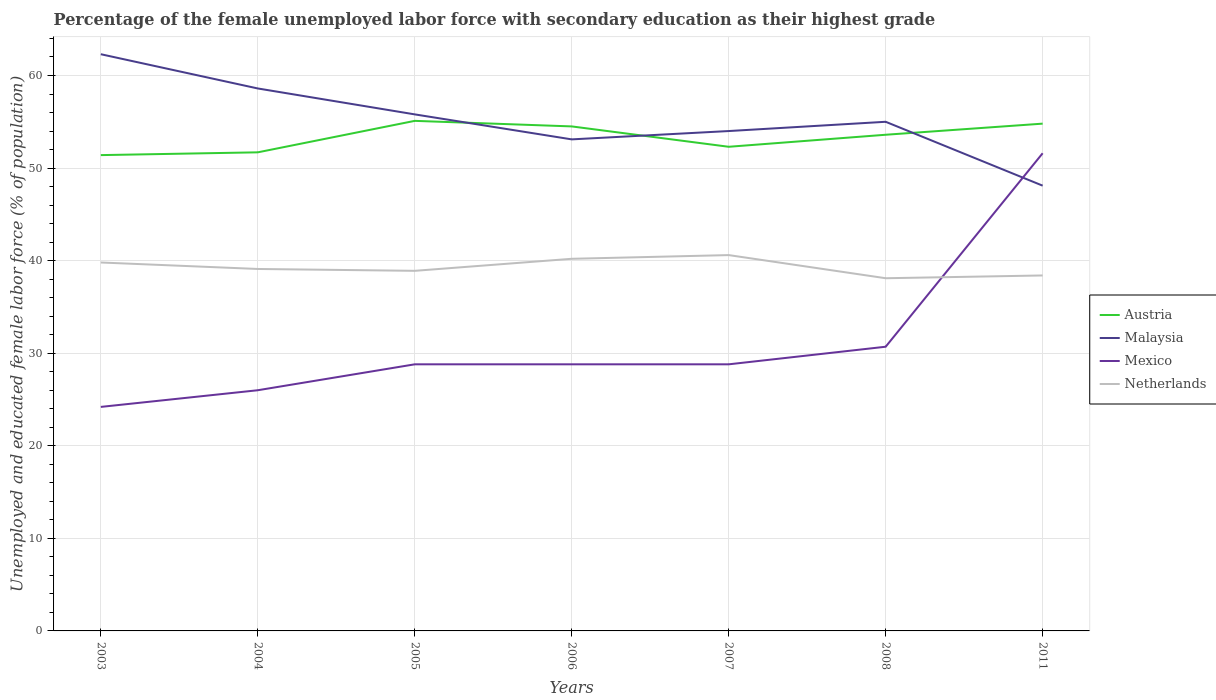How many different coloured lines are there?
Make the answer very short. 4. Does the line corresponding to Austria intersect with the line corresponding to Netherlands?
Give a very brief answer. No. Is the number of lines equal to the number of legend labels?
Make the answer very short. Yes. Across all years, what is the maximum percentage of the unemployed female labor force with secondary education in Austria?
Your response must be concise. 51.4. In which year was the percentage of the unemployed female labor force with secondary education in Malaysia maximum?
Provide a short and direct response. 2011. What is the total percentage of the unemployed female labor force with secondary education in Mexico in the graph?
Your answer should be compact. -25.6. What is the difference between the highest and the second highest percentage of the unemployed female labor force with secondary education in Netherlands?
Your answer should be compact. 2.5. What is the difference between the highest and the lowest percentage of the unemployed female labor force with secondary education in Austria?
Your answer should be very brief. 4. Is the percentage of the unemployed female labor force with secondary education in Austria strictly greater than the percentage of the unemployed female labor force with secondary education in Mexico over the years?
Your answer should be compact. No. What is the difference between two consecutive major ticks on the Y-axis?
Provide a short and direct response. 10. Are the values on the major ticks of Y-axis written in scientific E-notation?
Provide a succinct answer. No. Where does the legend appear in the graph?
Ensure brevity in your answer.  Center right. How are the legend labels stacked?
Ensure brevity in your answer.  Vertical. What is the title of the graph?
Your response must be concise. Percentage of the female unemployed labor force with secondary education as their highest grade. Does "Middle income" appear as one of the legend labels in the graph?
Your answer should be compact. No. What is the label or title of the Y-axis?
Your answer should be compact. Unemployed and educated female labor force (% of population). What is the Unemployed and educated female labor force (% of population) of Austria in 2003?
Your response must be concise. 51.4. What is the Unemployed and educated female labor force (% of population) in Malaysia in 2003?
Provide a succinct answer. 62.3. What is the Unemployed and educated female labor force (% of population) in Mexico in 2003?
Your response must be concise. 24.2. What is the Unemployed and educated female labor force (% of population) in Netherlands in 2003?
Keep it short and to the point. 39.8. What is the Unemployed and educated female labor force (% of population) in Austria in 2004?
Give a very brief answer. 51.7. What is the Unemployed and educated female labor force (% of population) in Malaysia in 2004?
Ensure brevity in your answer.  58.6. What is the Unemployed and educated female labor force (% of population) in Netherlands in 2004?
Your answer should be compact. 39.1. What is the Unemployed and educated female labor force (% of population) of Austria in 2005?
Give a very brief answer. 55.1. What is the Unemployed and educated female labor force (% of population) in Malaysia in 2005?
Ensure brevity in your answer.  55.8. What is the Unemployed and educated female labor force (% of population) of Mexico in 2005?
Your answer should be very brief. 28.8. What is the Unemployed and educated female labor force (% of population) in Netherlands in 2005?
Make the answer very short. 38.9. What is the Unemployed and educated female labor force (% of population) in Austria in 2006?
Make the answer very short. 54.5. What is the Unemployed and educated female labor force (% of population) of Malaysia in 2006?
Your answer should be very brief. 53.1. What is the Unemployed and educated female labor force (% of population) in Mexico in 2006?
Your answer should be very brief. 28.8. What is the Unemployed and educated female labor force (% of population) of Netherlands in 2006?
Your response must be concise. 40.2. What is the Unemployed and educated female labor force (% of population) in Austria in 2007?
Offer a very short reply. 52.3. What is the Unemployed and educated female labor force (% of population) in Malaysia in 2007?
Provide a succinct answer. 54. What is the Unemployed and educated female labor force (% of population) in Mexico in 2007?
Provide a short and direct response. 28.8. What is the Unemployed and educated female labor force (% of population) of Netherlands in 2007?
Provide a short and direct response. 40.6. What is the Unemployed and educated female labor force (% of population) in Austria in 2008?
Ensure brevity in your answer.  53.6. What is the Unemployed and educated female labor force (% of population) of Malaysia in 2008?
Give a very brief answer. 55. What is the Unemployed and educated female labor force (% of population) in Mexico in 2008?
Provide a succinct answer. 30.7. What is the Unemployed and educated female labor force (% of population) of Netherlands in 2008?
Offer a terse response. 38.1. What is the Unemployed and educated female labor force (% of population) in Austria in 2011?
Provide a short and direct response. 54.8. What is the Unemployed and educated female labor force (% of population) in Malaysia in 2011?
Provide a short and direct response. 48.1. What is the Unemployed and educated female labor force (% of population) of Mexico in 2011?
Your answer should be compact. 51.6. What is the Unemployed and educated female labor force (% of population) in Netherlands in 2011?
Offer a very short reply. 38.4. Across all years, what is the maximum Unemployed and educated female labor force (% of population) of Austria?
Keep it short and to the point. 55.1. Across all years, what is the maximum Unemployed and educated female labor force (% of population) of Malaysia?
Keep it short and to the point. 62.3. Across all years, what is the maximum Unemployed and educated female labor force (% of population) in Mexico?
Offer a very short reply. 51.6. Across all years, what is the maximum Unemployed and educated female labor force (% of population) in Netherlands?
Ensure brevity in your answer.  40.6. Across all years, what is the minimum Unemployed and educated female labor force (% of population) in Austria?
Provide a short and direct response. 51.4. Across all years, what is the minimum Unemployed and educated female labor force (% of population) of Malaysia?
Ensure brevity in your answer.  48.1. Across all years, what is the minimum Unemployed and educated female labor force (% of population) in Mexico?
Give a very brief answer. 24.2. Across all years, what is the minimum Unemployed and educated female labor force (% of population) in Netherlands?
Your answer should be very brief. 38.1. What is the total Unemployed and educated female labor force (% of population) of Austria in the graph?
Ensure brevity in your answer.  373.4. What is the total Unemployed and educated female labor force (% of population) of Malaysia in the graph?
Provide a short and direct response. 386.9. What is the total Unemployed and educated female labor force (% of population) of Mexico in the graph?
Keep it short and to the point. 218.9. What is the total Unemployed and educated female labor force (% of population) of Netherlands in the graph?
Make the answer very short. 275.1. What is the difference between the Unemployed and educated female labor force (% of population) in Austria in 2003 and that in 2004?
Your response must be concise. -0.3. What is the difference between the Unemployed and educated female labor force (% of population) in Netherlands in 2003 and that in 2004?
Offer a terse response. 0.7. What is the difference between the Unemployed and educated female labor force (% of population) in Austria in 2003 and that in 2005?
Give a very brief answer. -3.7. What is the difference between the Unemployed and educated female labor force (% of population) of Malaysia in 2003 and that in 2005?
Provide a succinct answer. 6.5. What is the difference between the Unemployed and educated female labor force (% of population) in Malaysia in 2003 and that in 2006?
Offer a very short reply. 9.2. What is the difference between the Unemployed and educated female labor force (% of population) of Mexico in 2003 and that in 2006?
Offer a very short reply. -4.6. What is the difference between the Unemployed and educated female labor force (% of population) of Austria in 2003 and that in 2007?
Offer a very short reply. -0.9. What is the difference between the Unemployed and educated female labor force (% of population) of Malaysia in 2003 and that in 2007?
Your answer should be very brief. 8.3. What is the difference between the Unemployed and educated female labor force (% of population) in Netherlands in 2003 and that in 2007?
Provide a short and direct response. -0.8. What is the difference between the Unemployed and educated female labor force (% of population) in Austria in 2003 and that in 2008?
Keep it short and to the point. -2.2. What is the difference between the Unemployed and educated female labor force (% of population) in Malaysia in 2003 and that in 2008?
Give a very brief answer. 7.3. What is the difference between the Unemployed and educated female labor force (% of population) of Netherlands in 2003 and that in 2008?
Offer a very short reply. 1.7. What is the difference between the Unemployed and educated female labor force (% of population) in Austria in 2003 and that in 2011?
Give a very brief answer. -3.4. What is the difference between the Unemployed and educated female labor force (% of population) in Mexico in 2003 and that in 2011?
Ensure brevity in your answer.  -27.4. What is the difference between the Unemployed and educated female labor force (% of population) of Netherlands in 2003 and that in 2011?
Offer a very short reply. 1.4. What is the difference between the Unemployed and educated female labor force (% of population) in Mexico in 2004 and that in 2005?
Offer a very short reply. -2.8. What is the difference between the Unemployed and educated female labor force (% of population) of Austria in 2004 and that in 2006?
Offer a very short reply. -2.8. What is the difference between the Unemployed and educated female labor force (% of population) in Mexico in 2004 and that in 2006?
Provide a short and direct response. -2.8. What is the difference between the Unemployed and educated female labor force (% of population) of Netherlands in 2004 and that in 2006?
Provide a short and direct response. -1.1. What is the difference between the Unemployed and educated female labor force (% of population) in Austria in 2004 and that in 2007?
Make the answer very short. -0.6. What is the difference between the Unemployed and educated female labor force (% of population) of Mexico in 2004 and that in 2007?
Ensure brevity in your answer.  -2.8. What is the difference between the Unemployed and educated female labor force (% of population) of Netherlands in 2004 and that in 2007?
Your response must be concise. -1.5. What is the difference between the Unemployed and educated female labor force (% of population) in Austria in 2004 and that in 2008?
Your answer should be very brief. -1.9. What is the difference between the Unemployed and educated female labor force (% of population) of Malaysia in 2004 and that in 2008?
Provide a short and direct response. 3.6. What is the difference between the Unemployed and educated female labor force (% of population) in Mexico in 2004 and that in 2008?
Provide a short and direct response. -4.7. What is the difference between the Unemployed and educated female labor force (% of population) of Austria in 2004 and that in 2011?
Your answer should be very brief. -3.1. What is the difference between the Unemployed and educated female labor force (% of population) of Mexico in 2004 and that in 2011?
Give a very brief answer. -25.6. What is the difference between the Unemployed and educated female labor force (% of population) in Netherlands in 2004 and that in 2011?
Provide a short and direct response. 0.7. What is the difference between the Unemployed and educated female labor force (% of population) in Austria in 2005 and that in 2006?
Give a very brief answer. 0.6. What is the difference between the Unemployed and educated female labor force (% of population) in Netherlands in 2005 and that in 2006?
Offer a terse response. -1.3. What is the difference between the Unemployed and educated female labor force (% of population) of Mexico in 2005 and that in 2007?
Give a very brief answer. 0. What is the difference between the Unemployed and educated female labor force (% of population) in Austria in 2005 and that in 2008?
Provide a short and direct response. 1.5. What is the difference between the Unemployed and educated female labor force (% of population) of Malaysia in 2005 and that in 2008?
Give a very brief answer. 0.8. What is the difference between the Unemployed and educated female labor force (% of population) of Netherlands in 2005 and that in 2008?
Offer a terse response. 0.8. What is the difference between the Unemployed and educated female labor force (% of population) of Austria in 2005 and that in 2011?
Your response must be concise. 0.3. What is the difference between the Unemployed and educated female labor force (% of population) in Malaysia in 2005 and that in 2011?
Give a very brief answer. 7.7. What is the difference between the Unemployed and educated female labor force (% of population) in Mexico in 2005 and that in 2011?
Offer a very short reply. -22.8. What is the difference between the Unemployed and educated female labor force (% of population) of Netherlands in 2005 and that in 2011?
Your answer should be very brief. 0.5. What is the difference between the Unemployed and educated female labor force (% of population) of Austria in 2006 and that in 2007?
Offer a terse response. 2.2. What is the difference between the Unemployed and educated female labor force (% of population) in Malaysia in 2006 and that in 2007?
Provide a succinct answer. -0.9. What is the difference between the Unemployed and educated female labor force (% of population) in Mexico in 2006 and that in 2007?
Offer a very short reply. 0. What is the difference between the Unemployed and educated female labor force (% of population) in Malaysia in 2006 and that in 2008?
Provide a succinct answer. -1.9. What is the difference between the Unemployed and educated female labor force (% of population) in Mexico in 2006 and that in 2008?
Your answer should be compact. -1.9. What is the difference between the Unemployed and educated female labor force (% of population) in Austria in 2006 and that in 2011?
Provide a short and direct response. -0.3. What is the difference between the Unemployed and educated female labor force (% of population) of Malaysia in 2006 and that in 2011?
Keep it short and to the point. 5. What is the difference between the Unemployed and educated female labor force (% of population) in Mexico in 2006 and that in 2011?
Provide a short and direct response. -22.8. What is the difference between the Unemployed and educated female labor force (% of population) in Malaysia in 2007 and that in 2008?
Your answer should be compact. -1. What is the difference between the Unemployed and educated female labor force (% of population) in Mexico in 2007 and that in 2008?
Your answer should be very brief. -1.9. What is the difference between the Unemployed and educated female labor force (% of population) in Mexico in 2007 and that in 2011?
Keep it short and to the point. -22.8. What is the difference between the Unemployed and educated female labor force (% of population) of Netherlands in 2007 and that in 2011?
Offer a very short reply. 2.2. What is the difference between the Unemployed and educated female labor force (% of population) of Austria in 2008 and that in 2011?
Give a very brief answer. -1.2. What is the difference between the Unemployed and educated female labor force (% of population) in Mexico in 2008 and that in 2011?
Provide a short and direct response. -20.9. What is the difference between the Unemployed and educated female labor force (% of population) of Austria in 2003 and the Unemployed and educated female labor force (% of population) of Mexico in 2004?
Provide a short and direct response. 25.4. What is the difference between the Unemployed and educated female labor force (% of population) in Austria in 2003 and the Unemployed and educated female labor force (% of population) in Netherlands in 2004?
Offer a very short reply. 12.3. What is the difference between the Unemployed and educated female labor force (% of population) in Malaysia in 2003 and the Unemployed and educated female labor force (% of population) in Mexico in 2004?
Provide a succinct answer. 36.3. What is the difference between the Unemployed and educated female labor force (% of population) in Malaysia in 2003 and the Unemployed and educated female labor force (% of population) in Netherlands in 2004?
Keep it short and to the point. 23.2. What is the difference between the Unemployed and educated female labor force (% of population) in Mexico in 2003 and the Unemployed and educated female labor force (% of population) in Netherlands in 2004?
Offer a terse response. -14.9. What is the difference between the Unemployed and educated female labor force (% of population) of Austria in 2003 and the Unemployed and educated female labor force (% of population) of Malaysia in 2005?
Offer a terse response. -4.4. What is the difference between the Unemployed and educated female labor force (% of population) of Austria in 2003 and the Unemployed and educated female labor force (% of population) of Mexico in 2005?
Provide a short and direct response. 22.6. What is the difference between the Unemployed and educated female labor force (% of population) in Malaysia in 2003 and the Unemployed and educated female labor force (% of population) in Mexico in 2005?
Ensure brevity in your answer.  33.5. What is the difference between the Unemployed and educated female labor force (% of population) of Malaysia in 2003 and the Unemployed and educated female labor force (% of population) of Netherlands in 2005?
Provide a short and direct response. 23.4. What is the difference between the Unemployed and educated female labor force (% of population) of Mexico in 2003 and the Unemployed and educated female labor force (% of population) of Netherlands in 2005?
Your answer should be very brief. -14.7. What is the difference between the Unemployed and educated female labor force (% of population) of Austria in 2003 and the Unemployed and educated female labor force (% of population) of Malaysia in 2006?
Provide a succinct answer. -1.7. What is the difference between the Unemployed and educated female labor force (% of population) of Austria in 2003 and the Unemployed and educated female labor force (% of population) of Mexico in 2006?
Give a very brief answer. 22.6. What is the difference between the Unemployed and educated female labor force (% of population) of Malaysia in 2003 and the Unemployed and educated female labor force (% of population) of Mexico in 2006?
Provide a succinct answer. 33.5. What is the difference between the Unemployed and educated female labor force (% of population) of Malaysia in 2003 and the Unemployed and educated female labor force (% of population) of Netherlands in 2006?
Offer a very short reply. 22.1. What is the difference between the Unemployed and educated female labor force (% of population) in Austria in 2003 and the Unemployed and educated female labor force (% of population) in Mexico in 2007?
Your response must be concise. 22.6. What is the difference between the Unemployed and educated female labor force (% of population) of Austria in 2003 and the Unemployed and educated female labor force (% of population) of Netherlands in 2007?
Your answer should be compact. 10.8. What is the difference between the Unemployed and educated female labor force (% of population) of Malaysia in 2003 and the Unemployed and educated female labor force (% of population) of Mexico in 2007?
Your answer should be compact. 33.5. What is the difference between the Unemployed and educated female labor force (% of population) of Malaysia in 2003 and the Unemployed and educated female labor force (% of population) of Netherlands in 2007?
Offer a very short reply. 21.7. What is the difference between the Unemployed and educated female labor force (% of population) in Mexico in 2003 and the Unemployed and educated female labor force (% of population) in Netherlands in 2007?
Make the answer very short. -16.4. What is the difference between the Unemployed and educated female labor force (% of population) in Austria in 2003 and the Unemployed and educated female labor force (% of population) in Malaysia in 2008?
Your answer should be compact. -3.6. What is the difference between the Unemployed and educated female labor force (% of population) of Austria in 2003 and the Unemployed and educated female labor force (% of population) of Mexico in 2008?
Make the answer very short. 20.7. What is the difference between the Unemployed and educated female labor force (% of population) of Malaysia in 2003 and the Unemployed and educated female labor force (% of population) of Mexico in 2008?
Keep it short and to the point. 31.6. What is the difference between the Unemployed and educated female labor force (% of population) in Malaysia in 2003 and the Unemployed and educated female labor force (% of population) in Netherlands in 2008?
Provide a short and direct response. 24.2. What is the difference between the Unemployed and educated female labor force (% of population) in Austria in 2003 and the Unemployed and educated female labor force (% of population) in Malaysia in 2011?
Your answer should be compact. 3.3. What is the difference between the Unemployed and educated female labor force (% of population) of Austria in 2003 and the Unemployed and educated female labor force (% of population) of Mexico in 2011?
Your answer should be compact. -0.2. What is the difference between the Unemployed and educated female labor force (% of population) of Malaysia in 2003 and the Unemployed and educated female labor force (% of population) of Mexico in 2011?
Give a very brief answer. 10.7. What is the difference between the Unemployed and educated female labor force (% of population) of Malaysia in 2003 and the Unemployed and educated female labor force (% of population) of Netherlands in 2011?
Your response must be concise. 23.9. What is the difference between the Unemployed and educated female labor force (% of population) of Mexico in 2003 and the Unemployed and educated female labor force (% of population) of Netherlands in 2011?
Offer a terse response. -14.2. What is the difference between the Unemployed and educated female labor force (% of population) in Austria in 2004 and the Unemployed and educated female labor force (% of population) in Malaysia in 2005?
Provide a short and direct response. -4.1. What is the difference between the Unemployed and educated female labor force (% of population) in Austria in 2004 and the Unemployed and educated female labor force (% of population) in Mexico in 2005?
Give a very brief answer. 22.9. What is the difference between the Unemployed and educated female labor force (% of population) in Austria in 2004 and the Unemployed and educated female labor force (% of population) in Netherlands in 2005?
Your answer should be very brief. 12.8. What is the difference between the Unemployed and educated female labor force (% of population) in Malaysia in 2004 and the Unemployed and educated female labor force (% of population) in Mexico in 2005?
Offer a terse response. 29.8. What is the difference between the Unemployed and educated female labor force (% of population) of Malaysia in 2004 and the Unemployed and educated female labor force (% of population) of Netherlands in 2005?
Your answer should be compact. 19.7. What is the difference between the Unemployed and educated female labor force (% of population) of Mexico in 2004 and the Unemployed and educated female labor force (% of population) of Netherlands in 2005?
Offer a terse response. -12.9. What is the difference between the Unemployed and educated female labor force (% of population) in Austria in 2004 and the Unemployed and educated female labor force (% of population) in Malaysia in 2006?
Give a very brief answer. -1.4. What is the difference between the Unemployed and educated female labor force (% of population) in Austria in 2004 and the Unemployed and educated female labor force (% of population) in Mexico in 2006?
Make the answer very short. 22.9. What is the difference between the Unemployed and educated female labor force (% of population) in Austria in 2004 and the Unemployed and educated female labor force (% of population) in Netherlands in 2006?
Offer a very short reply. 11.5. What is the difference between the Unemployed and educated female labor force (% of population) in Malaysia in 2004 and the Unemployed and educated female labor force (% of population) in Mexico in 2006?
Keep it short and to the point. 29.8. What is the difference between the Unemployed and educated female labor force (% of population) of Austria in 2004 and the Unemployed and educated female labor force (% of population) of Mexico in 2007?
Your answer should be compact. 22.9. What is the difference between the Unemployed and educated female labor force (% of population) of Malaysia in 2004 and the Unemployed and educated female labor force (% of population) of Mexico in 2007?
Offer a terse response. 29.8. What is the difference between the Unemployed and educated female labor force (% of population) in Malaysia in 2004 and the Unemployed and educated female labor force (% of population) in Netherlands in 2007?
Your answer should be compact. 18. What is the difference between the Unemployed and educated female labor force (% of population) in Mexico in 2004 and the Unemployed and educated female labor force (% of population) in Netherlands in 2007?
Your answer should be very brief. -14.6. What is the difference between the Unemployed and educated female labor force (% of population) in Austria in 2004 and the Unemployed and educated female labor force (% of population) in Malaysia in 2008?
Your answer should be very brief. -3.3. What is the difference between the Unemployed and educated female labor force (% of population) in Malaysia in 2004 and the Unemployed and educated female labor force (% of population) in Mexico in 2008?
Provide a short and direct response. 27.9. What is the difference between the Unemployed and educated female labor force (% of population) in Malaysia in 2004 and the Unemployed and educated female labor force (% of population) in Mexico in 2011?
Offer a very short reply. 7. What is the difference between the Unemployed and educated female labor force (% of population) in Malaysia in 2004 and the Unemployed and educated female labor force (% of population) in Netherlands in 2011?
Keep it short and to the point. 20.2. What is the difference between the Unemployed and educated female labor force (% of population) in Austria in 2005 and the Unemployed and educated female labor force (% of population) in Malaysia in 2006?
Keep it short and to the point. 2. What is the difference between the Unemployed and educated female labor force (% of population) in Austria in 2005 and the Unemployed and educated female labor force (% of population) in Mexico in 2006?
Your response must be concise. 26.3. What is the difference between the Unemployed and educated female labor force (% of population) in Austria in 2005 and the Unemployed and educated female labor force (% of population) in Netherlands in 2006?
Your answer should be compact. 14.9. What is the difference between the Unemployed and educated female labor force (% of population) in Malaysia in 2005 and the Unemployed and educated female labor force (% of population) in Mexico in 2006?
Keep it short and to the point. 27. What is the difference between the Unemployed and educated female labor force (% of population) in Mexico in 2005 and the Unemployed and educated female labor force (% of population) in Netherlands in 2006?
Keep it short and to the point. -11.4. What is the difference between the Unemployed and educated female labor force (% of population) of Austria in 2005 and the Unemployed and educated female labor force (% of population) of Mexico in 2007?
Provide a short and direct response. 26.3. What is the difference between the Unemployed and educated female labor force (% of population) of Austria in 2005 and the Unemployed and educated female labor force (% of population) of Netherlands in 2007?
Offer a very short reply. 14.5. What is the difference between the Unemployed and educated female labor force (% of population) of Malaysia in 2005 and the Unemployed and educated female labor force (% of population) of Mexico in 2007?
Your response must be concise. 27. What is the difference between the Unemployed and educated female labor force (% of population) of Malaysia in 2005 and the Unemployed and educated female labor force (% of population) of Netherlands in 2007?
Give a very brief answer. 15.2. What is the difference between the Unemployed and educated female labor force (% of population) of Mexico in 2005 and the Unemployed and educated female labor force (% of population) of Netherlands in 2007?
Keep it short and to the point. -11.8. What is the difference between the Unemployed and educated female labor force (% of population) of Austria in 2005 and the Unemployed and educated female labor force (% of population) of Malaysia in 2008?
Make the answer very short. 0.1. What is the difference between the Unemployed and educated female labor force (% of population) in Austria in 2005 and the Unemployed and educated female labor force (% of population) in Mexico in 2008?
Ensure brevity in your answer.  24.4. What is the difference between the Unemployed and educated female labor force (% of population) in Malaysia in 2005 and the Unemployed and educated female labor force (% of population) in Mexico in 2008?
Provide a succinct answer. 25.1. What is the difference between the Unemployed and educated female labor force (% of population) of Malaysia in 2005 and the Unemployed and educated female labor force (% of population) of Netherlands in 2008?
Your response must be concise. 17.7. What is the difference between the Unemployed and educated female labor force (% of population) in Mexico in 2005 and the Unemployed and educated female labor force (% of population) in Netherlands in 2008?
Your answer should be very brief. -9.3. What is the difference between the Unemployed and educated female labor force (% of population) of Austria in 2005 and the Unemployed and educated female labor force (% of population) of Mexico in 2011?
Offer a terse response. 3.5. What is the difference between the Unemployed and educated female labor force (% of population) of Austria in 2005 and the Unemployed and educated female labor force (% of population) of Netherlands in 2011?
Offer a terse response. 16.7. What is the difference between the Unemployed and educated female labor force (% of population) of Austria in 2006 and the Unemployed and educated female labor force (% of population) of Mexico in 2007?
Provide a succinct answer. 25.7. What is the difference between the Unemployed and educated female labor force (% of population) of Malaysia in 2006 and the Unemployed and educated female labor force (% of population) of Mexico in 2007?
Your response must be concise. 24.3. What is the difference between the Unemployed and educated female labor force (% of population) of Austria in 2006 and the Unemployed and educated female labor force (% of population) of Malaysia in 2008?
Provide a short and direct response. -0.5. What is the difference between the Unemployed and educated female labor force (% of population) of Austria in 2006 and the Unemployed and educated female labor force (% of population) of Mexico in 2008?
Offer a very short reply. 23.8. What is the difference between the Unemployed and educated female labor force (% of population) in Malaysia in 2006 and the Unemployed and educated female labor force (% of population) in Mexico in 2008?
Your answer should be compact. 22.4. What is the difference between the Unemployed and educated female labor force (% of population) of Mexico in 2006 and the Unemployed and educated female labor force (% of population) of Netherlands in 2008?
Offer a very short reply. -9.3. What is the difference between the Unemployed and educated female labor force (% of population) of Austria in 2006 and the Unemployed and educated female labor force (% of population) of Malaysia in 2011?
Offer a terse response. 6.4. What is the difference between the Unemployed and educated female labor force (% of population) in Austria in 2006 and the Unemployed and educated female labor force (% of population) in Mexico in 2011?
Provide a short and direct response. 2.9. What is the difference between the Unemployed and educated female labor force (% of population) in Malaysia in 2006 and the Unemployed and educated female labor force (% of population) in Mexico in 2011?
Provide a succinct answer. 1.5. What is the difference between the Unemployed and educated female labor force (% of population) of Malaysia in 2006 and the Unemployed and educated female labor force (% of population) of Netherlands in 2011?
Provide a short and direct response. 14.7. What is the difference between the Unemployed and educated female labor force (% of population) of Austria in 2007 and the Unemployed and educated female labor force (% of population) of Malaysia in 2008?
Make the answer very short. -2.7. What is the difference between the Unemployed and educated female labor force (% of population) of Austria in 2007 and the Unemployed and educated female labor force (% of population) of Mexico in 2008?
Keep it short and to the point. 21.6. What is the difference between the Unemployed and educated female labor force (% of population) of Malaysia in 2007 and the Unemployed and educated female labor force (% of population) of Mexico in 2008?
Ensure brevity in your answer.  23.3. What is the difference between the Unemployed and educated female labor force (% of population) in Mexico in 2007 and the Unemployed and educated female labor force (% of population) in Netherlands in 2008?
Your answer should be very brief. -9.3. What is the difference between the Unemployed and educated female labor force (% of population) of Austria in 2007 and the Unemployed and educated female labor force (% of population) of Netherlands in 2011?
Ensure brevity in your answer.  13.9. What is the difference between the Unemployed and educated female labor force (% of population) in Malaysia in 2007 and the Unemployed and educated female labor force (% of population) in Netherlands in 2011?
Your response must be concise. 15.6. What is the difference between the Unemployed and educated female labor force (% of population) in Malaysia in 2008 and the Unemployed and educated female labor force (% of population) in Mexico in 2011?
Your answer should be very brief. 3.4. What is the difference between the Unemployed and educated female labor force (% of population) of Malaysia in 2008 and the Unemployed and educated female labor force (% of population) of Netherlands in 2011?
Offer a very short reply. 16.6. What is the average Unemployed and educated female labor force (% of population) in Austria per year?
Give a very brief answer. 53.34. What is the average Unemployed and educated female labor force (% of population) in Malaysia per year?
Provide a short and direct response. 55.27. What is the average Unemployed and educated female labor force (% of population) of Mexico per year?
Your answer should be very brief. 31.27. What is the average Unemployed and educated female labor force (% of population) in Netherlands per year?
Make the answer very short. 39.3. In the year 2003, what is the difference between the Unemployed and educated female labor force (% of population) in Austria and Unemployed and educated female labor force (% of population) in Malaysia?
Offer a very short reply. -10.9. In the year 2003, what is the difference between the Unemployed and educated female labor force (% of population) in Austria and Unemployed and educated female labor force (% of population) in Mexico?
Ensure brevity in your answer.  27.2. In the year 2003, what is the difference between the Unemployed and educated female labor force (% of population) of Austria and Unemployed and educated female labor force (% of population) of Netherlands?
Your answer should be compact. 11.6. In the year 2003, what is the difference between the Unemployed and educated female labor force (% of population) in Malaysia and Unemployed and educated female labor force (% of population) in Mexico?
Ensure brevity in your answer.  38.1. In the year 2003, what is the difference between the Unemployed and educated female labor force (% of population) of Mexico and Unemployed and educated female labor force (% of population) of Netherlands?
Make the answer very short. -15.6. In the year 2004, what is the difference between the Unemployed and educated female labor force (% of population) of Austria and Unemployed and educated female labor force (% of population) of Malaysia?
Keep it short and to the point. -6.9. In the year 2004, what is the difference between the Unemployed and educated female labor force (% of population) of Austria and Unemployed and educated female labor force (% of population) of Mexico?
Ensure brevity in your answer.  25.7. In the year 2004, what is the difference between the Unemployed and educated female labor force (% of population) in Austria and Unemployed and educated female labor force (% of population) in Netherlands?
Your response must be concise. 12.6. In the year 2004, what is the difference between the Unemployed and educated female labor force (% of population) in Malaysia and Unemployed and educated female labor force (% of population) in Mexico?
Make the answer very short. 32.6. In the year 2004, what is the difference between the Unemployed and educated female labor force (% of population) of Malaysia and Unemployed and educated female labor force (% of population) of Netherlands?
Your answer should be very brief. 19.5. In the year 2004, what is the difference between the Unemployed and educated female labor force (% of population) in Mexico and Unemployed and educated female labor force (% of population) in Netherlands?
Your answer should be compact. -13.1. In the year 2005, what is the difference between the Unemployed and educated female labor force (% of population) in Austria and Unemployed and educated female labor force (% of population) in Malaysia?
Your answer should be compact. -0.7. In the year 2005, what is the difference between the Unemployed and educated female labor force (% of population) in Austria and Unemployed and educated female labor force (% of population) in Mexico?
Offer a terse response. 26.3. In the year 2005, what is the difference between the Unemployed and educated female labor force (% of population) in Austria and Unemployed and educated female labor force (% of population) in Netherlands?
Keep it short and to the point. 16.2. In the year 2005, what is the difference between the Unemployed and educated female labor force (% of population) in Malaysia and Unemployed and educated female labor force (% of population) in Mexico?
Your answer should be very brief. 27. In the year 2006, what is the difference between the Unemployed and educated female labor force (% of population) in Austria and Unemployed and educated female labor force (% of population) in Malaysia?
Provide a short and direct response. 1.4. In the year 2006, what is the difference between the Unemployed and educated female labor force (% of population) of Austria and Unemployed and educated female labor force (% of population) of Mexico?
Offer a terse response. 25.7. In the year 2006, what is the difference between the Unemployed and educated female labor force (% of population) of Austria and Unemployed and educated female labor force (% of population) of Netherlands?
Ensure brevity in your answer.  14.3. In the year 2006, what is the difference between the Unemployed and educated female labor force (% of population) in Malaysia and Unemployed and educated female labor force (% of population) in Mexico?
Provide a succinct answer. 24.3. In the year 2006, what is the difference between the Unemployed and educated female labor force (% of population) of Malaysia and Unemployed and educated female labor force (% of population) of Netherlands?
Your response must be concise. 12.9. In the year 2006, what is the difference between the Unemployed and educated female labor force (% of population) of Mexico and Unemployed and educated female labor force (% of population) of Netherlands?
Offer a very short reply. -11.4. In the year 2007, what is the difference between the Unemployed and educated female labor force (% of population) in Austria and Unemployed and educated female labor force (% of population) in Malaysia?
Your answer should be compact. -1.7. In the year 2007, what is the difference between the Unemployed and educated female labor force (% of population) of Austria and Unemployed and educated female labor force (% of population) of Netherlands?
Make the answer very short. 11.7. In the year 2007, what is the difference between the Unemployed and educated female labor force (% of population) of Malaysia and Unemployed and educated female labor force (% of population) of Mexico?
Provide a succinct answer. 25.2. In the year 2007, what is the difference between the Unemployed and educated female labor force (% of population) in Mexico and Unemployed and educated female labor force (% of population) in Netherlands?
Keep it short and to the point. -11.8. In the year 2008, what is the difference between the Unemployed and educated female labor force (% of population) of Austria and Unemployed and educated female labor force (% of population) of Mexico?
Your response must be concise. 22.9. In the year 2008, what is the difference between the Unemployed and educated female labor force (% of population) in Austria and Unemployed and educated female labor force (% of population) in Netherlands?
Provide a succinct answer. 15.5. In the year 2008, what is the difference between the Unemployed and educated female labor force (% of population) in Malaysia and Unemployed and educated female labor force (% of population) in Mexico?
Give a very brief answer. 24.3. In the year 2011, what is the difference between the Unemployed and educated female labor force (% of population) of Malaysia and Unemployed and educated female labor force (% of population) of Mexico?
Your answer should be very brief. -3.5. In the year 2011, what is the difference between the Unemployed and educated female labor force (% of population) of Mexico and Unemployed and educated female labor force (% of population) of Netherlands?
Offer a very short reply. 13.2. What is the ratio of the Unemployed and educated female labor force (% of population) in Austria in 2003 to that in 2004?
Your response must be concise. 0.99. What is the ratio of the Unemployed and educated female labor force (% of population) in Malaysia in 2003 to that in 2004?
Provide a short and direct response. 1.06. What is the ratio of the Unemployed and educated female labor force (% of population) in Mexico in 2003 to that in 2004?
Keep it short and to the point. 0.93. What is the ratio of the Unemployed and educated female labor force (% of population) in Netherlands in 2003 to that in 2004?
Your answer should be compact. 1.02. What is the ratio of the Unemployed and educated female labor force (% of population) in Austria in 2003 to that in 2005?
Provide a short and direct response. 0.93. What is the ratio of the Unemployed and educated female labor force (% of population) in Malaysia in 2003 to that in 2005?
Offer a terse response. 1.12. What is the ratio of the Unemployed and educated female labor force (% of population) in Mexico in 2003 to that in 2005?
Your answer should be compact. 0.84. What is the ratio of the Unemployed and educated female labor force (% of population) of Netherlands in 2003 to that in 2005?
Offer a terse response. 1.02. What is the ratio of the Unemployed and educated female labor force (% of population) in Austria in 2003 to that in 2006?
Provide a succinct answer. 0.94. What is the ratio of the Unemployed and educated female labor force (% of population) of Malaysia in 2003 to that in 2006?
Provide a short and direct response. 1.17. What is the ratio of the Unemployed and educated female labor force (% of population) of Mexico in 2003 to that in 2006?
Your answer should be compact. 0.84. What is the ratio of the Unemployed and educated female labor force (% of population) in Netherlands in 2003 to that in 2006?
Keep it short and to the point. 0.99. What is the ratio of the Unemployed and educated female labor force (% of population) in Austria in 2003 to that in 2007?
Offer a terse response. 0.98. What is the ratio of the Unemployed and educated female labor force (% of population) of Malaysia in 2003 to that in 2007?
Provide a succinct answer. 1.15. What is the ratio of the Unemployed and educated female labor force (% of population) in Mexico in 2003 to that in 2007?
Your answer should be very brief. 0.84. What is the ratio of the Unemployed and educated female labor force (% of population) in Netherlands in 2003 to that in 2007?
Provide a succinct answer. 0.98. What is the ratio of the Unemployed and educated female labor force (% of population) in Austria in 2003 to that in 2008?
Ensure brevity in your answer.  0.96. What is the ratio of the Unemployed and educated female labor force (% of population) in Malaysia in 2003 to that in 2008?
Keep it short and to the point. 1.13. What is the ratio of the Unemployed and educated female labor force (% of population) in Mexico in 2003 to that in 2008?
Your response must be concise. 0.79. What is the ratio of the Unemployed and educated female labor force (% of population) of Netherlands in 2003 to that in 2008?
Provide a short and direct response. 1.04. What is the ratio of the Unemployed and educated female labor force (% of population) in Austria in 2003 to that in 2011?
Give a very brief answer. 0.94. What is the ratio of the Unemployed and educated female labor force (% of population) of Malaysia in 2003 to that in 2011?
Give a very brief answer. 1.3. What is the ratio of the Unemployed and educated female labor force (% of population) in Mexico in 2003 to that in 2011?
Keep it short and to the point. 0.47. What is the ratio of the Unemployed and educated female labor force (% of population) in Netherlands in 2003 to that in 2011?
Make the answer very short. 1.04. What is the ratio of the Unemployed and educated female labor force (% of population) of Austria in 2004 to that in 2005?
Ensure brevity in your answer.  0.94. What is the ratio of the Unemployed and educated female labor force (% of population) in Malaysia in 2004 to that in 2005?
Your answer should be very brief. 1.05. What is the ratio of the Unemployed and educated female labor force (% of population) of Mexico in 2004 to that in 2005?
Ensure brevity in your answer.  0.9. What is the ratio of the Unemployed and educated female labor force (% of population) of Austria in 2004 to that in 2006?
Make the answer very short. 0.95. What is the ratio of the Unemployed and educated female labor force (% of population) in Malaysia in 2004 to that in 2006?
Give a very brief answer. 1.1. What is the ratio of the Unemployed and educated female labor force (% of population) in Mexico in 2004 to that in 2006?
Ensure brevity in your answer.  0.9. What is the ratio of the Unemployed and educated female labor force (% of population) of Netherlands in 2004 to that in 2006?
Your response must be concise. 0.97. What is the ratio of the Unemployed and educated female labor force (% of population) of Austria in 2004 to that in 2007?
Offer a terse response. 0.99. What is the ratio of the Unemployed and educated female labor force (% of population) of Malaysia in 2004 to that in 2007?
Keep it short and to the point. 1.09. What is the ratio of the Unemployed and educated female labor force (% of population) of Mexico in 2004 to that in 2007?
Make the answer very short. 0.9. What is the ratio of the Unemployed and educated female labor force (% of population) of Netherlands in 2004 to that in 2007?
Keep it short and to the point. 0.96. What is the ratio of the Unemployed and educated female labor force (% of population) of Austria in 2004 to that in 2008?
Your answer should be very brief. 0.96. What is the ratio of the Unemployed and educated female labor force (% of population) of Malaysia in 2004 to that in 2008?
Your response must be concise. 1.07. What is the ratio of the Unemployed and educated female labor force (% of population) of Mexico in 2004 to that in 2008?
Offer a very short reply. 0.85. What is the ratio of the Unemployed and educated female labor force (% of population) of Netherlands in 2004 to that in 2008?
Give a very brief answer. 1.03. What is the ratio of the Unemployed and educated female labor force (% of population) in Austria in 2004 to that in 2011?
Your answer should be very brief. 0.94. What is the ratio of the Unemployed and educated female labor force (% of population) in Malaysia in 2004 to that in 2011?
Your answer should be very brief. 1.22. What is the ratio of the Unemployed and educated female labor force (% of population) of Mexico in 2004 to that in 2011?
Give a very brief answer. 0.5. What is the ratio of the Unemployed and educated female labor force (% of population) of Netherlands in 2004 to that in 2011?
Give a very brief answer. 1.02. What is the ratio of the Unemployed and educated female labor force (% of population) in Austria in 2005 to that in 2006?
Provide a short and direct response. 1.01. What is the ratio of the Unemployed and educated female labor force (% of population) of Malaysia in 2005 to that in 2006?
Your answer should be very brief. 1.05. What is the ratio of the Unemployed and educated female labor force (% of population) of Mexico in 2005 to that in 2006?
Make the answer very short. 1. What is the ratio of the Unemployed and educated female labor force (% of population) in Austria in 2005 to that in 2007?
Ensure brevity in your answer.  1.05. What is the ratio of the Unemployed and educated female labor force (% of population) of Mexico in 2005 to that in 2007?
Your answer should be compact. 1. What is the ratio of the Unemployed and educated female labor force (% of population) in Netherlands in 2005 to that in 2007?
Make the answer very short. 0.96. What is the ratio of the Unemployed and educated female labor force (% of population) in Austria in 2005 to that in 2008?
Provide a succinct answer. 1.03. What is the ratio of the Unemployed and educated female labor force (% of population) of Malaysia in 2005 to that in 2008?
Ensure brevity in your answer.  1.01. What is the ratio of the Unemployed and educated female labor force (% of population) of Mexico in 2005 to that in 2008?
Your answer should be compact. 0.94. What is the ratio of the Unemployed and educated female labor force (% of population) in Austria in 2005 to that in 2011?
Give a very brief answer. 1.01. What is the ratio of the Unemployed and educated female labor force (% of population) of Malaysia in 2005 to that in 2011?
Give a very brief answer. 1.16. What is the ratio of the Unemployed and educated female labor force (% of population) in Mexico in 2005 to that in 2011?
Give a very brief answer. 0.56. What is the ratio of the Unemployed and educated female labor force (% of population) of Netherlands in 2005 to that in 2011?
Your answer should be very brief. 1.01. What is the ratio of the Unemployed and educated female labor force (% of population) of Austria in 2006 to that in 2007?
Provide a succinct answer. 1.04. What is the ratio of the Unemployed and educated female labor force (% of population) of Malaysia in 2006 to that in 2007?
Provide a succinct answer. 0.98. What is the ratio of the Unemployed and educated female labor force (% of population) of Mexico in 2006 to that in 2007?
Your answer should be compact. 1. What is the ratio of the Unemployed and educated female labor force (% of population) of Netherlands in 2006 to that in 2007?
Ensure brevity in your answer.  0.99. What is the ratio of the Unemployed and educated female labor force (% of population) in Austria in 2006 to that in 2008?
Your response must be concise. 1.02. What is the ratio of the Unemployed and educated female labor force (% of population) of Malaysia in 2006 to that in 2008?
Your answer should be very brief. 0.97. What is the ratio of the Unemployed and educated female labor force (% of population) in Mexico in 2006 to that in 2008?
Keep it short and to the point. 0.94. What is the ratio of the Unemployed and educated female labor force (% of population) of Netherlands in 2006 to that in 2008?
Offer a terse response. 1.06. What is the ratio of the Unemployed and educated female labor force (% of population) of Malaysia in 2006 to that in 2011?
Your answer should be very brief. 1.1. What is the ratio of the Unemployed and educated female labor force (% of population) in Mexico in 2006 to that in 2011?
Offer a terse response. 0.56. What is the ratio of the Unemployed and educated female labor force (% of population) in Netherlands in 2006 to that in 2011?
Make the answer very short. 1.05. What is the ratio of the Unemployed and educated female labor force (% of population) in Austria in 2007 to that in 2008?
Provide a short and direct response. 0.98. What is the ratio of the Unemployed and educated female labor force (% of population) in Malaysia in 2007 to that in 2008?
Your answer should be very brief. 0.98. What is the ratio of the Unemployed and educated female labor force (% of population) of Mexico in 2007 to that in 2008?
Offer a terse response. 0.94. What is the ratio of the Unemployed and educated female labor force (% of population) in Netherlands in 2007 to that in 2008?
Provide a short and direct response. 1.07. What is the ratio of the Unemployed and educated female labor force (% of population) of Austria in 2007 to that in 2011?
Keep it short and to the point. 0.95. What is the ratio of the Unemployed and educated female labor force (% of population) of Malaysia in 2007 to that in 2011?
Offer a terse response. 1.12. What is the ratio of the Unemployed and educated female labor force (% of population) of Mexico in 2007 to that in 2011?
Give a very brief answer. 0.56. What is the ratio of the Unemployed and educated female labor force (% of population) in Netherlands in 2007 to that in 2011?
Your answer should be compact. 1.06. What is the ratio of the Unemployed and educated female labor force (% of population) of Austria in 2008 to that in 2011?
Offer a very short reply. 0.98. What is the ratio of the Unemployed and educated female labor force (% of population) of Malaysia in 2008 to that in 2011?
Give a very brief answer. 1.14. What is the ratio of the Unemployed and educated female labor force (% of population) in Mexico in 2008 to that in 2011?
Make the answer very short. 0.59. What is the ratio of the Unemployed and educated female labor force (% of population) in Netherlands in 2008 to that in 2011?
Keep it short and to the point. 0.99. What is the difference between the highest and the second highest Unemployed and educated female labor force (% of population) of Malaysia?
Provide a short and direct response. 3.7. What is the difference between the highest and the second highest Unemployed and educated female labor force (% of population) of Mexico?
Offer a very short reply. 20.9. What is the difference between the highest and the lowest Unemployed and educated female labor force (% of population) of Austria?
Offer a very short reply. 3.7. What is the difference between the highest and the lowest Unemployed and educated female labor force (% of population) of Malaysia?
Provide a short and direct response. 14.2. What is the difference between the highest and the lowest Unemployed and educated female labor force (% of population) of Mexico?
Ensure brevity in your answer.  27.4. 